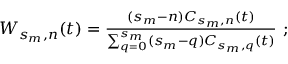Convert formula to latex. <formula><loc_0><loc_0><loc_500><loc_500>\begin{array} { r } { W _ { s _ { m } , n } ( t ) = \frac { ( s _ { m } - n ) C _ { s _ { m } , n } ( t ) } { \sum _ { q = 0 } ^ { s _ { m } } ( s _ { m } - q ) C _ { s _ { m } , q } ( t ) } ; } \end{array}</formula> 